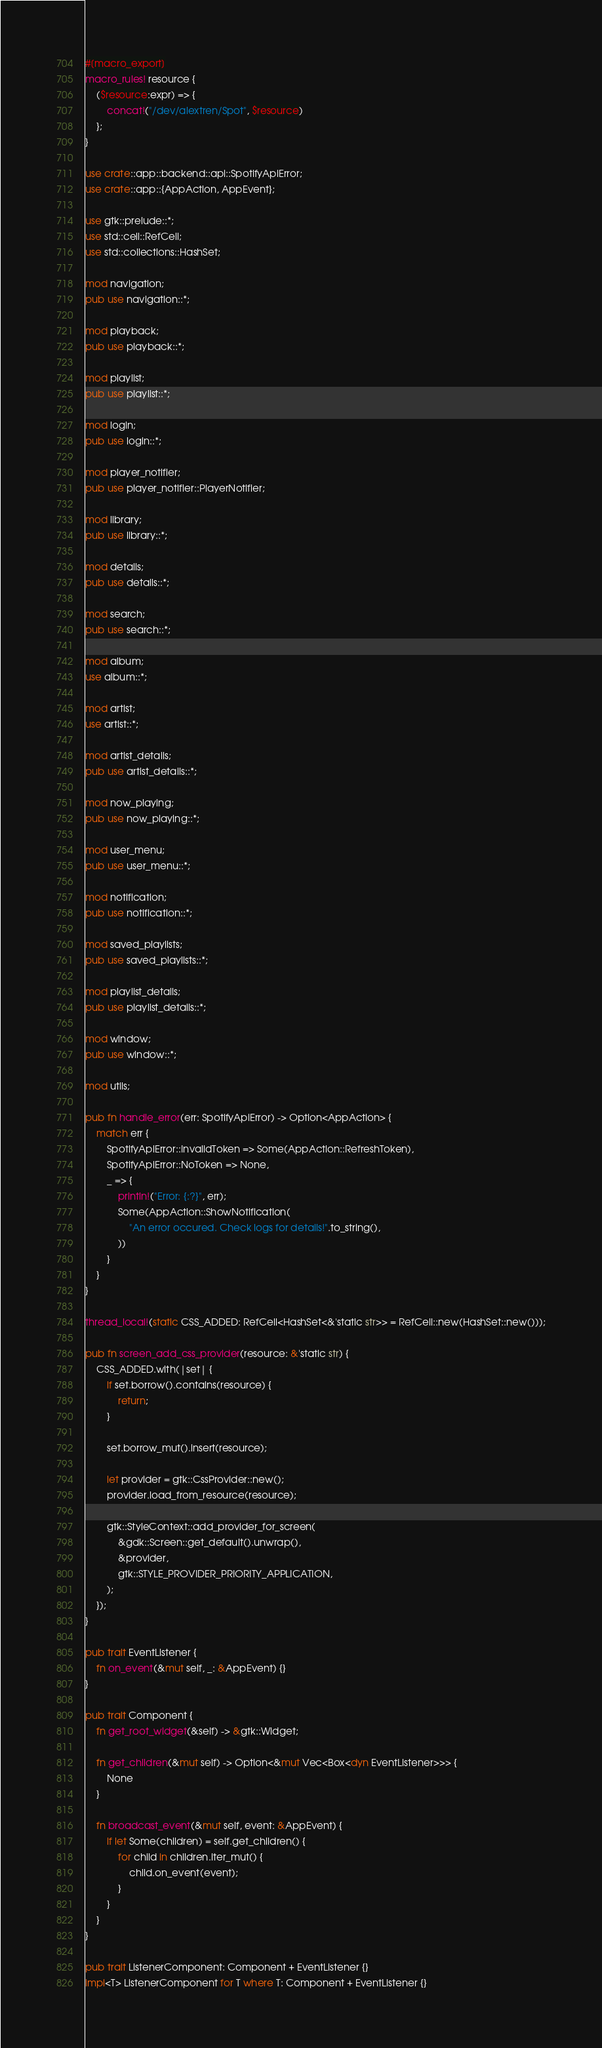Convert code to text. <code><loc_0><loc_0><loc_500><loc_500><_Rust_>#[macro_export]
macro_rules! resource {
    ($resource:expr) => {
        concat!("/dev/alextren/Spot", $resource)
    };
}

use crate::app::backend::api::SpotifyApiError;
use crate::app::{AppAction, AppEvent};

use gtk::prelude::*;
use std::cell::RefCell;
use std::collections::HashSet;

mod navigation;
pub use navigation::*;

mod playback;
pub use playback::*;

mod playlist;
pub use playlist::*;

mod login;
pub use login::*;

mod player_notifier;
pub use player_notifier::PlayerNotifier;

mod library;
pub use library::*;

mod details;
pub use details::*;

mod search;
pub use search::*;

mod album;
use album::*;

mod artist;
use artist::*;

mod artist_details;
pub use artist_details::*;

mod now_playing;
pub use now_playing::*;

mod user_menu;
pub use user_menu::*;

mod notification;
pub use notification::*;

mod saved_playlists;
pub use saved_playlists::*;

mod playlist_details;
pub use playlist_details::*;

mod window;
pub use window::*;

mod utils;

pub fn handle_error(err: SpotifyApiError) -> Option<AppAction> {
    match err {
        SpotifyApiError::InvalidToken => Some(AppAction::RefreshToken),
        SpotifyApiError::NoToken => None,
        _ => {
            println!("Error: {:?}", err);
            Some(AppAction::ShowNotification(
                "An error occured. Check logs for details!".to_string(),
            ))
        }
    }
}

thread_local!(static CSS_ADDED: RefCell<HashSet<&'static str>> = RefCell::new(HashSet::new()));

pub fn screen_add_css_provider(resource: &'static str) {
    CSS_ADDED.with(|set| {
        if set.borrow().contains(resource) {
            return;
        }

        set.borrow_mut().insert(resource);

        let provider = gtk::CssProvider::new();
        provider.load_from_resource(resource);

        gtk::StyleContext::add_provider_for_screen(
            &gdk::Screen::get_default().unwrap(),
            &provider,
            gtk::STYLE_PROVIDER_PRIORITY_APPLICATION,
        );
    });
}

pub trait EventListener {
    fn on_event(&mut self, _: &AppEvent) {}
}

pub trait Component {
    fn get_root_widget(&self) -> &gtk::Widget;

    fn get_children(&mut self) -> Option<&mut Vec<Box<dyn EventListener>>> {
        None
    }

    fn broadcast_event(&mut self, event: &AppEvent) {
        if let Some(children) = self.get_children() {
            for child in children.iter_mut() {
                child.on_event(event);
            }
        }
    }
}

pub trait ListenerComponent: Component + EventListener {}
impl<T> ListenerComponent for T where T: Component + EventListener {}
</code> 